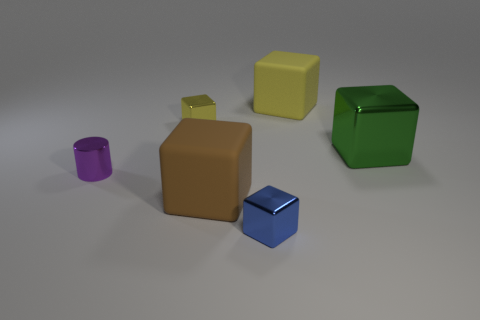Do the rubber cube that is left of the blue thing and the purple metallic object have the same size?
Provide a short and direct response. No. Are there any other things that have the same color as the big metallic block?
Offer a terse response. No. There is a small yellow metallic object; what shape is it?
Provide a short and direct response. Cube. What number of shiny things are in front of the green shiny thing and right of the small yellow shiny block?
Provide a succinct answer. 1. Do the cylinder and the large shiny thing have the same color?
Keep it short and to the point. No. There is a large brown object that is the same shape as the yellow matte thing; what is it made of?
Your answer should be very brief. Rubber. Is there anything else that has the same material as the cylinder?
Ensure brevity in your answer.  Yes. Is the number of large brown things that are right of the small purple object the same as the number of shiny things in front of the brown rubber cube?
Your answer should be compact. Yes. Is the big yellow thing made of the same material as the big green object?
Offer a terse response. No. What number of blue objects are either small cylinders or big matte things?
Ensure brevity in your answer.  0. 